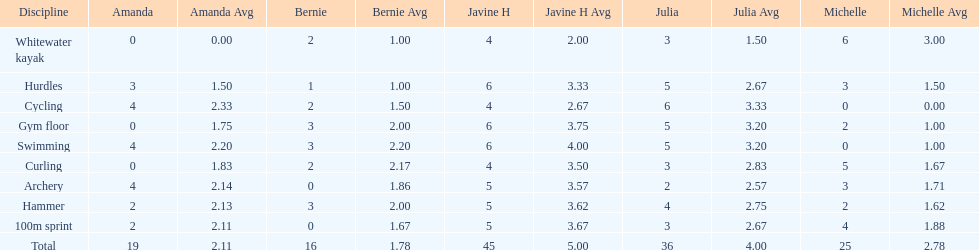Would you be able to parse every entry in this table? {'header': ['Discipline', 'Amanda', 'Amanda Avg', 'Bernie', 'Bernie Avg', 'Javine H', 'Javine H Avg', 'Julia', 'Julia Avg', 'Michelle', 'Michelle Avg'], 'rows': [['Whitewater kayak', '0', '0.00', '2', '1.00', '4', '2.00', '3', '1.50', '6', '3.00'], ['Hurdles', '3', '1.50', '1', '1.00', '6', '3.33', '5', '2.67', '3', '1.50'], ['Cycling', '4', '2.33', '2', '1.50', '4', '2.67', '6', '3.33', '0', '0.00'], ['Gym floor', '0', '1.75', '3', '2.00', '6', '3.75', '5', '3.20', '2', '1.00'], ['Swimming', '4', '2.20', '3', '2.20', '6', '4.00', '5', '3.20', '0', '1.00'], ['Curling', '0', '1.83', '2', '2.17', '4', '3.50', '3', '2.83', '5', '1.67'], ['Archery', '4', '2.14', '0', '1.86', '5', '3.57', '2', '2.57', '3', '1.71'], ['Hammer', '2', '2.13', '3', '2.00', '5', '3.62', '4', '2.75', '2', '1.62'], ['100m sprint', '2', '2.11', '0', '1.67', '5', '3.67', '3', '2.67', '4', '1.88'], ['Total', '19', '2.11', '16', '1.78', '45', '5.00', '36', '4.00', '25', '2.78']]} Name a girl that had the same score in cycling and archery. Amanda. 